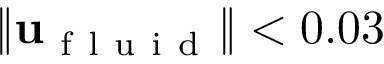<formula> <loc_0><loc_0><loc_500><loc_500>\| u _ { f l u i d } \| < 0 . 0 3</formula> 